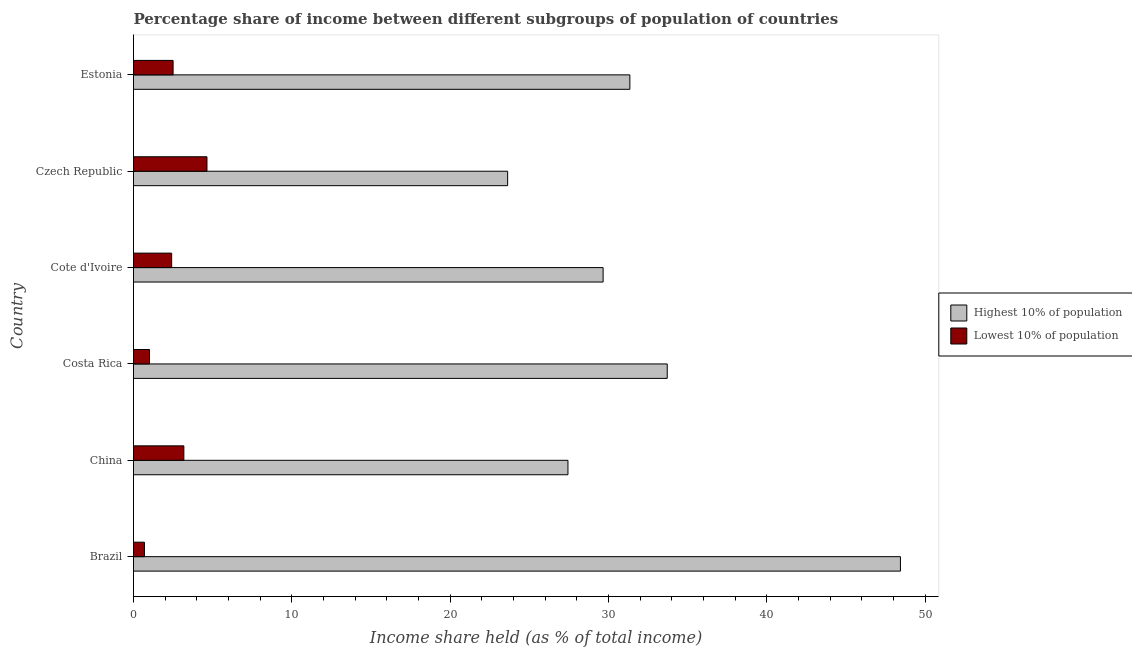How many groups of bars are there?
Make the answer very short. 6. Are the number of bars per tick equal to the number of legend labels?
Your response must be concise. Yes. How many bars are there on the 3rd tick from the bottom?
Provide a succinct answer. 2. What is the label of the 1st group of bars from the top?
Keep it short and to the point. Estonia. In how many cases, is the number of bars for a given country not equal to the number of legend labels?
Provide a short and direct response. 0. What is the income share held by highest 10% of the population in Czech Republic?
Keep it short and to the point. 23.63. Across all countries, what is the maximum income share held by highest 10% of the population?
Keep it short and to the point. 48.44. Across all countries, what is the minimum income share held by lowest 10% of the population?
Your response must be concise. 0.69. In which country was the income share held by lowest 10% of the population maximum?
Your answer should be compact. Czech Republic. What is the total income share held by lowest 10% of the population in the graph?
Your answer should be very brief. 14.43. What is the difference between the income share held by highest 10% of the population in Brazil and that in Czech Republic?
Your answer should be compact. 24.81. What is the difference between the income share held by lowest 10% of the population in Costa Rica and the income share held by highest 10% of the population in Brazil?
Your answer should be very brief. -47.43. What is the average income share held by lowest 10% of the population per country?
Offer a terse response. 2.4. What is the difference between the income share held by lowest 10% of the population and income share held by highest 10% of the population in Costa Rica?
Give a very brief answer. -32.7. In how many countries, is the income share held by highest 10% of the population greater than 28 %?
Keep it short and to the point. 4. What is the ratio of the income share held by highest 10% of the population in China to that in Costa Rica?
Provide a succinct answer. 0.81. Is the income share held by lowest 10% of the population in Brazil less than that in Czech Republic?
Your answer should be very brief. Yes. What is the difference between the highest and the second highest income share held by lowest 10% of the population?
Provide a short and direct response. 1.46. What is the difference between the highest and the lowest income share held by lowest 10% of the population?
Keep it short and to the point. 3.95. In how many countries, is the income share held by lowest 10% of the population greater than the average income share held by lowest 10% of the population taken over all countries?
Offer a terse response. 4. What does the 2nd bar from the top in Estonia represents?
Make the answer very short. Highest 10% of population. What does the 1st bar from the bottom in Cote d'Ivoire represents?
Ensure brevity in your answer.  Highest 10% of population. How many countries are there in the graph?
Your answer should be very brief. 6. Does the graph contain grids?
Your answer should be very brief. No. Where does the legend appear in the graph?
Offer a very short reply. Center right. How are the legend labels stacked?
Provide a succinct answer. Vertical. What is the title of the graph?
Your answer should be compact. Percentage share of income between different subgroups of population of countries. What is the label or title of the X-axis?
Provide a short and direct response. Income share held (as % of total income). What is the label or title of the Y-axis?
Offer a very short reply. Country. What is the Income share held (as % of total income) in Highest 10% of population in Brazil?
Offer a terse response. 48.44. What is the Income share held (as % of total income) of Lowest 10% of population in Brazil?
Give a very brief answer. 0.69. What is the Income share held (as % of total income) of Highest 10% of population in China?
Ensure brevity in your answer.  27.44. What is the Income share held (as % of total income) in Lowest 10% of population in China?
Provide a short and direct response. 3.18. What is the Income share held (as % of total income) in Highest 10% of population in Costa Rica?
Offer a very short reply. 33.71. What is the Income share held (as % of total income) in Highest 10% of population in Cote d'Ivoire?
Keep it short and to the point. 29.66. What is the Income share held (as % of total income) of Lowest 10% of population in Cote d'Ivoire?
Ensure brevity in your answer.  2.41. What is the Income share held (as % of total income) of Highest 10% of population in Czech Republic?
Provide a short and direct response. 23.63. What is the Income share held (as % of total income) of Lowest 10% of population in Czech Republic?
Offer a terse response. 4.64. What is the Income share held (as % of total income) in Highest 10% of population in Estonia?
Offer a very short reply. 31.35. Across all countries, what is the maximum Income share held (as % of total income) in Highest 10% of population?
Your answer should be compact. 48.44. Across all countries, what is the maximum Income share held (as % of total income) of Lowest 10% of population?
Provide a succinct answer. 4.64. Across all countries, what is the minimum Income share held (as % of total income) of Highest 10% of population?
Your response must be concise. 23.63. Across all countries, what is the minimum Income share held (as % of total income) of Lowest 10% of population?
Offer a very short reply. 0.69. What is the total Income share held (as % of total income) in Highest 10% of population in the graph?
Your response must be concise. 194.23. What is the total Income share held (as % of total income) in Lowest 10% of population in the graph?
Provide a succinct answer. 14.43. What is the difference between the Income share held (as % of total income) of Highest 10% of population in Brazil and that in China?
Provide a short and direct response. 21. What is the difference between the Income share held (as % of total income) in Lowest 10% of population in Brazil and that in China?
Keep it short and to the point. -2.49. What is the difference between the Income share held (as % of total income) of Highest 10% of population in Brazil and that in Costa Rica?
Offer a terse response. 14.73. What is the difference between the Income share held (as % of total income) of Lowest 10% of population in Brazil and that in Costa Rica?
Your response must be concise. -0.32. What is the difference between the Income share held (as % of total income) of Highest 10% of population in Brazil and that in Cote d'Ivoire?
Your response must be concise. 18.78. What is the difference between the Income share held (as % of total income) of Lowest 10% of population in Brazil and that in Cote d'Ivoire?
Give a very brief answer. -1.72. What is the difference between the Income share held (as % of total income) in Highest 10% of population in Brazil and that in Czech Republic?
Provide a short and direct response. 24.81. What is the difference between the Income share held (as % of total income) in Lowest 10% of population in Brazil and that in Czech Republic?
Keep it short and to the point. -3.95. What is the difference between the Income share held (as % of total income) of Highest 10% of population in Brazil and that in Estonia?
Ensure brevity in your answer.  17.09. What is the difference between the Income share held (as % of total income) in Lowest 10% of population in Brazil and that in Estonia?
Ensure brevity in your answer.  -1.81. What is the difference between the Income share held (as % of total income) in Highest 10% of population in China and that in Costa Rica?
Make the answer very short. -6.27. What is the difference between the Income share held (as % of total income) of Lowest 10% of population in China and that in Costa Rica?
Offer a terse response. 2.17. What is the difference between the Income share held (as % of total income) of Highest 10% of population in China and that in Cote d'Ivoire?
Offer a very short reply. -2.22. What is the difference between the Income share held (as % of total income) in Lowest 10% of population in China and that in Cote d'Ivoire?
Provide a short and direct response. 0.77. What is the difference between the Income share held (as % of total income) in Highest 10% of population in China and that in Czech Republic?
Give a very brief answer. 3.81. What is the difference between the Income share held (as % of total income) of Lowest 10% of population in China and that in Czech Republic?
Your answer should be very brief. -1.46. What is the difference between the Income share held (as % of total income) in Highest 10% of population in China and that in Estonia?
Your answer should be very brief. -3.91. What is the difference between the Income share held (as % of total income) of Lowest 10% of population in China and that in Estonia?
Keep it short and to the point. 0.68. What is the difference between the Income share held (as % of total income) of Highest 10% of population in Costa Rica and that in Cote d'Ivoire?
Your response must be concise. 4.05. What is the difference between the Income share held (as % of total income) of Highest 10% of population in Costa Rica and that in Czech Republic?
Offer a terse response. 10.08. What is the difference between the Income share held (as % of total income) of Lowest 10% of population in Costa Rica and that in Czech Republic?
Your response must be concise. -3.63. What is the difference between the Income share held (as % of total income) in Highest 10% of population in Costa Rica and that in Estonia?
Provide a short and direct response. 2.36. What is the difference between the Income share held (as % of total income) of Lowest 10% of population in Costa Rica and that in Estonia?
Provide a succinct answer. -1.49. What is the difference between the Income share held (as % of total income) in Highest 10% of population in Cote d'Ivoire and that in Czech Republic?
Provide a succinct answer. 6.03. What is the difference between the Income share held (as % of total income) in Lowest 10% of population in Cote d'Ivoire and that in Czech Republic?
Your answer should be very brief. -2.23. What is the difference between the Income share held (as % of total income) of Highest 10% of population in Cote d'Ivoire and that in Estonia?
Your answer should be compact. -1.69. What is the difference between the Income share held (as % of total income) of Lowest 10% of population in Cote d'Ivoire and that in Estonia?
Offer a terse response. -0.09. What is the difference between the Income share held (as % of total income) in Highest 10% of population in Czech Republic and that in Estonia?
Offer a terse response. -7.72. What is the difference between the Income share held (as % of total income) of Lowest 10% of population in Czech Republic and that in Estonia?
Make the answer very short. 2.14. What is the difference between the Income share held (as % of total income) of Highest 10% of population in Brazil and the Income share held (as % of total income) of Lowest 10% of population in China?
Offer a very short reply. 45.26. What is the difference between the Income share held (as % of total income) in Highest 10% of population in Brazil and the Income share held (as % of total income) in Lowest 10% of population in Costa Rica?
Keep it short and to the point. 47.43. What is the difference between the Income share held (as % of total income) of Highest 10% of population in Brazil and the Income share held (as % of total income) of Lowest 10% of population in Cote d'Ivoire?
Give a very brief answer. 46.03. What is the difference between the Income share held (as % of total income) of Highest 10% of population in Brazil and the Income share held (as % of total income) of Lowest 10% of population in Czech Republic?
Your answer should be very brief. 43.8. What is the difference between the Income share held (as % of total income) in Highest 10% of population in Brazil and the Income share held (as % of total income) in Lowest 10% of population in Estonia?
Your answer should be compact. 45.94. What is the difference between the Income share held (as % of total income) in Highest 10% of population in China and the Income share held (as % of total income) in Lowest 10% of population in Costa Rica?
Give a very brief answer. 26.43. What is the difference between the Income share held (as % of total income) in Highest 10% of population in China and the Income share held (as % of total income) in Lowest 10% of population in Cote d'Ivoire?
Your answer should be compact. 25.03. What is the difference between the Income share held (as % of total income) in Highest 10% of population in China and the Income share held (as % of total income) in Lowest 10% of population in Czech Republic?
Provide a short and direct response. 22.8. What is the difference between the Income share held (as % of total income) in Highest 10% of population in China and the Income share held (as % of total income) in Lowest 10% of population in Estonia?
Offer a very short reply. 24.94. What is the difference between the Income share held (as % of total income) in Highest 10% of population in Costa Rica and the Income share held (as % of total income) in Lowest 10% of population in Cote d'Ivoire?
Make the answer very short. 31.3. What is the difference between the Income share held (as % of total income) in Highest 10% of population in Costa Rica and the Income share held (as % of total income) in Lowest 10% of population in Czech Republic?
Keep it short and to the point. 29.07. What is the difference between the Income share held (as % of total income) of Highest 10% of population in Costa Rica and the Income share held (as % of total income) of Lowest 10% of population in Estonia?
Your response must be concise. 31.21. What is the difference between the Income share held (as % of total income) in Highest 10% of population in Cote d'Ivoire and the Income share held (as % of total income) in Lowest 10% of population in Czech Republic?
Ensure brevity in your answer.  25.02. What is the difference between the Income share held (as % of total income) in Highest 10% of population in Cote d'Ivoire and the Income share held (as % of total income) in Lowest 10% of population in Estonia?
Ensure brevity in your answer.  27.16. What is the difference between the Income share held (as % of total income) of Highest 10% of population in Czech Republic and the Income share held (as % of total income) of Lowest 10% of population in Estonia?
Your answer should be compact. 21.13. What is the average Income share held (as % of total income) of Highest 10% of population per country?
Give a very brief answer. 32.37. What is the average Income share held (as % of total income) of Lowest 10% of population per country?
Offer a terse response. 2.4. What is the difference between the Income share held (as % of total income) of Highest 10% of population and Income share held (as % of total income) of Lowest 10% of population in Brazil?
Make the answer very short. 47.75. What is the difference between the Income share held (as % of total income) in Highest 10% of population and Income share held (as % of total income) in Lowest 10% of population in China?
Keep it short and to the point. 24.26. What is the difference between the Income share held (as % of total income) in Highest 10% of population and Income share held (as % of total income) in Lowest 10% of population in Costa Rica?
Offer a terse response. 32.7. What is the difference between the Income share held (as % of total income) in Highest 10% of population and Income share held (as % of total income) in Lowest 10% of population in Cote d'Ivoire?
Provide a short and direct response. 27.25. What is the difference between the Income share held (as % of total income) in Highest 10% of population and Income share held (as % of total income) in Lowest 10% of population in Czech Republic?
Offer a terse response. 18.99. What is the difference between the Income share held (as % of total income) in Highest 10% of population and Income share held (as % of total income) in Lowest 10% of population in Estonia?
Your response must be concise. 28.85. What is the ratio of the Income share held (as % of total income) in Highest 10% of population in Brazil to that in China?
Give a very brief answer. 1.77. What is the ratio of the Income share held (as % of total income) of Lowest 10% of population in Brazil to that in China?
Offer a terse response. 0.22. What is the ratio of the Income share held (as % of total income) in Highest 10% of population in Brazil to that in Costa Rica?
Make the answer very short. 1.44. What is the ratio of the Income share held (as % of total income) in Lowest 10% of population in Brazil to that in Costa Rica?
Provide a short and direct response. 0.68. What is the ratio of the Income share held (as % of total income) of Highest 10% of population in Brazil to that in Cote d'Ivoire?
Give a very brief answer. 1.63. What is the ratio of the Income share held (as % of total income) in Lowest 10% of population in Brazil to that in Cote d'Ivoire?
Ensure brevity in your answer.  0.29. What is the ratio of the Income share held (as % of total income) of Highest 10% of population in Brazil to that in Czech Republic?
Keep it short and to the point. 2.05. What is the ratio of the Income share held (as % of total income) in Lowest 10% of population in Brazil to that in Czech Republic?
Give a very brief answer. 0.15. What is the ratio of the Income share held (as % of total income) in Highest 10% of population in Brazil to that in Estonia?
Your answer should be compact. 1.55. What is the ratio of the Income share held (as % of total income) in Lowest 10% of population in Brazil to that in Estonia?
Keep it short and to the point. 0.28. What is the ratio of the Income share held (as % of total income) in Highest 10% of population in China to that in Costa Rica?
Ensure brevity in your answer.  0.81. What is the ratio of the Income share held (as % of total income) of Lowest 10% of population in China to that in Costa Rica?
Your answer should be very brief. 3.15. What is the ratio of the Income share held (as % of total income) of Highest 10% of population in China to that in Cote d'Ivoire?
Ensure brevity in your answer.  0.93. What is the ratio of the Income share held (as % of total income) in Lowest 10% of population in China to that in Cote d'Ivoire?
Provide a succinct answer. 1.32. What is the ratio of the Income share held (as % of total income) in Highest 10% of population in China to that in Czech Republic?
Your response must be concise. 1.16. What is the ratio of the Income share held (as % of total income) in Lowest 10% of population in China to that in Czech Republic?
Keep it short and to the point. 0.69. What is the ratio of the Income share held (as % of total income) in Highest 10% of population in China to that in Estonia?
Your answer should be compact. 0.88. What is the ratio of the Income share held (as % of total income) of Lowest 10% of population in China to that in Estonia?
Your response must be concise. 1.27. What is the ratio of the Income share held (as % of total income) in Highest 10% of population in Costa Rica to that in Cote d'Ivoire?
Your answer should be compact. 1.14. What is the ratio of the Income share held (as % of total income) of Lowest 10% of population in Costa Rica to that in Cote d'Ivoire?
Offer a very short reply. 0.42. What is the ratio of the Income share held (as % of total income) of Highest 10% of population in Costa Rica to that in Czech Republic?
Your answer should be compact. 1.43. What is the ratio of the Income share held (as % of total income) in Lowest 10% of population in Costa Rica to that in Czech Republic?
Give a very brief answer. 0.22. What is the ratio of the Income share held (as % of total income) in Highest 10% of population in Costa Rica to that in Estonia?
Keep it short and to the point. 1.08. What is the ratio of the Income share held (as % of total income) of Lowest 10% of population in Costa Rica to that in Estonia?
Your response must be concise. 0.4. What is the ratio of the Income share held (as % of total income) in Highest 10% of population in Cote d'Ivoire to that in Czech Republic?
Your answer should be compact. 1.26. What is the ratio of the Income share held (as % of total income) in Lowest 10% of population in Cote d'Ivoire to that in Czech Republic?
Your answer should be compact. 0.52. What is the ratio of the Income share held (as % of total income) of Highest 10% of population in Cote d'Ivoire to that in Estonia?
Your answer should be very brief. 0.95. What is the ratio of the Income share held (as % of total income) of Highest 10% of population in Czech Republic to that in Estonia?
Your answer should be very brief. 0.75. What is the ratio of the Income share held (as % of total income) of Lowest 10% of population in Czech Republic to that in Estonia?
Provide a short and direct response. 1.86. What is the difference between the highest and the second highest Income share held (as % of total income) of Highest 10% of population?
Give a very brief answer. 14.73. What is the difference between the highest and the second highest Income share held (as % of total income) in Lowest 10% of population?
Offer a very short reply. 1.46. What is the difference between the highest and the lowest Income share held (as % of total income) in Highest 10% of population?
Provide a succinct answer. 24.81. What is the difference between the highest and the lowest Income share held (as % of total income) of Lowest 10% of population?
Offer a very short reply. 3.95. 